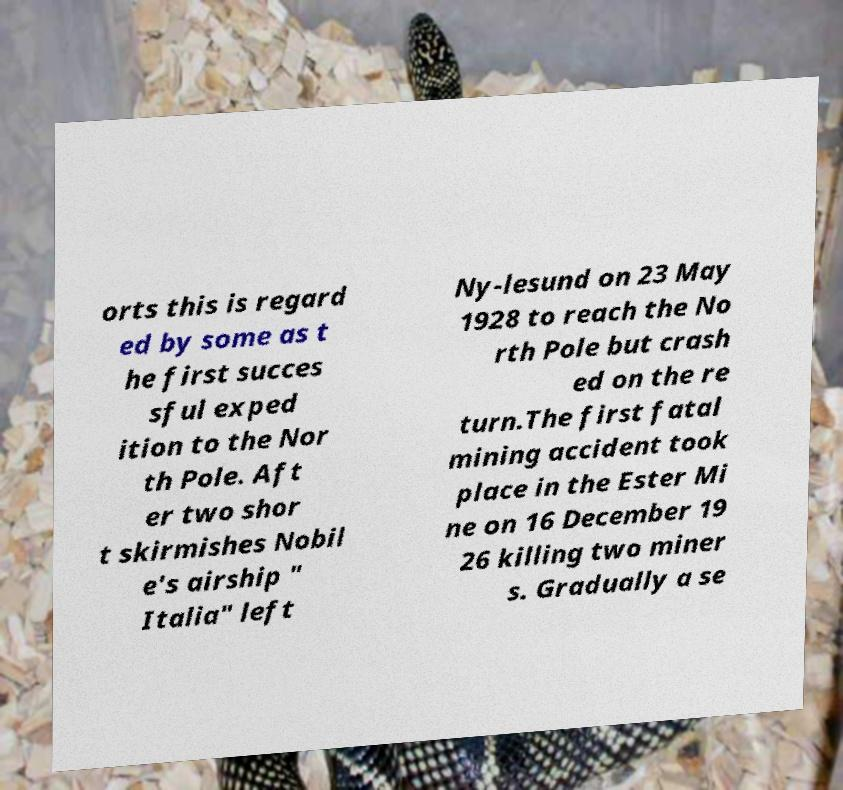Could you extract and type out the text from this image? orts this is regard ed by some as t he first succes sful exped ition to the Nor th Pole. Aft er two shor t skirmishes Nobil e's airship " Italia" left Ny-lesund on 23 May 1928 to reach the No rth Pole but crash ed on the re turn.The first fatal mining accident took place in the Ester Mi ne on 16 December 19 26 killing two miner s. Gradually a se 